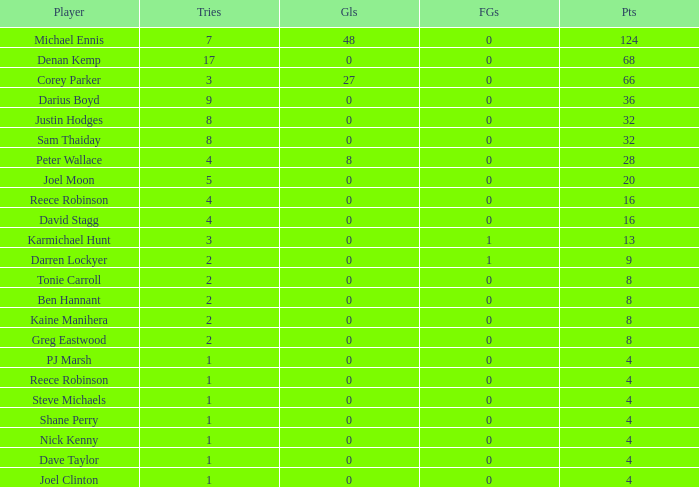What is the number of goals Dave Taylor, who has more than 1 tries, has? None. 